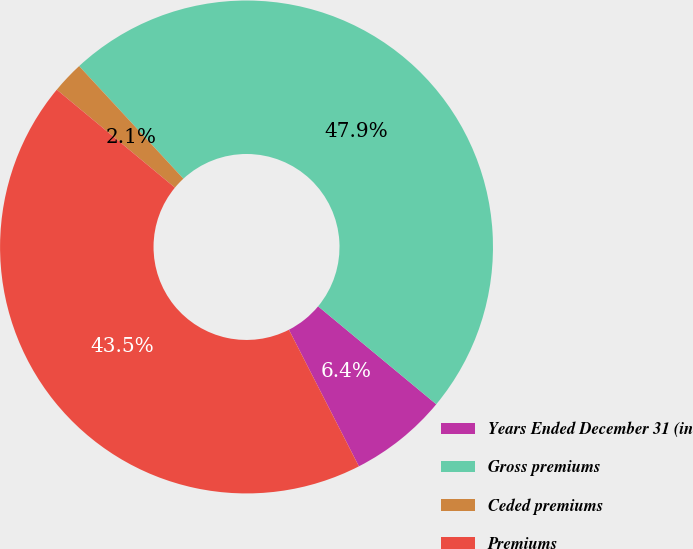Convert chart to OTSL. <chart><loc_0><loc_0><loc_500><loc_500><pie_chart><fcel>Years Ended December 31 (in<fcel>Gross premiums<fcel>Ceded premiums<fcel>Premiums<nl><fcel>6.45%<fcel>47.9%<fcel>2.1%<fcel>43.55%<nl></chart> 